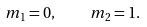Convert formula to latex. <formula><loc_0><loc_0><loc_500><loc_500>m _ { 1 } = 0 , \quad m _ { 2 } = 1 .</formula> 